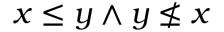Convert formula to latex. <formula><loc_0><loc_0><loc_500><loc_500>x \leq y \land y \nleq x</formula> 